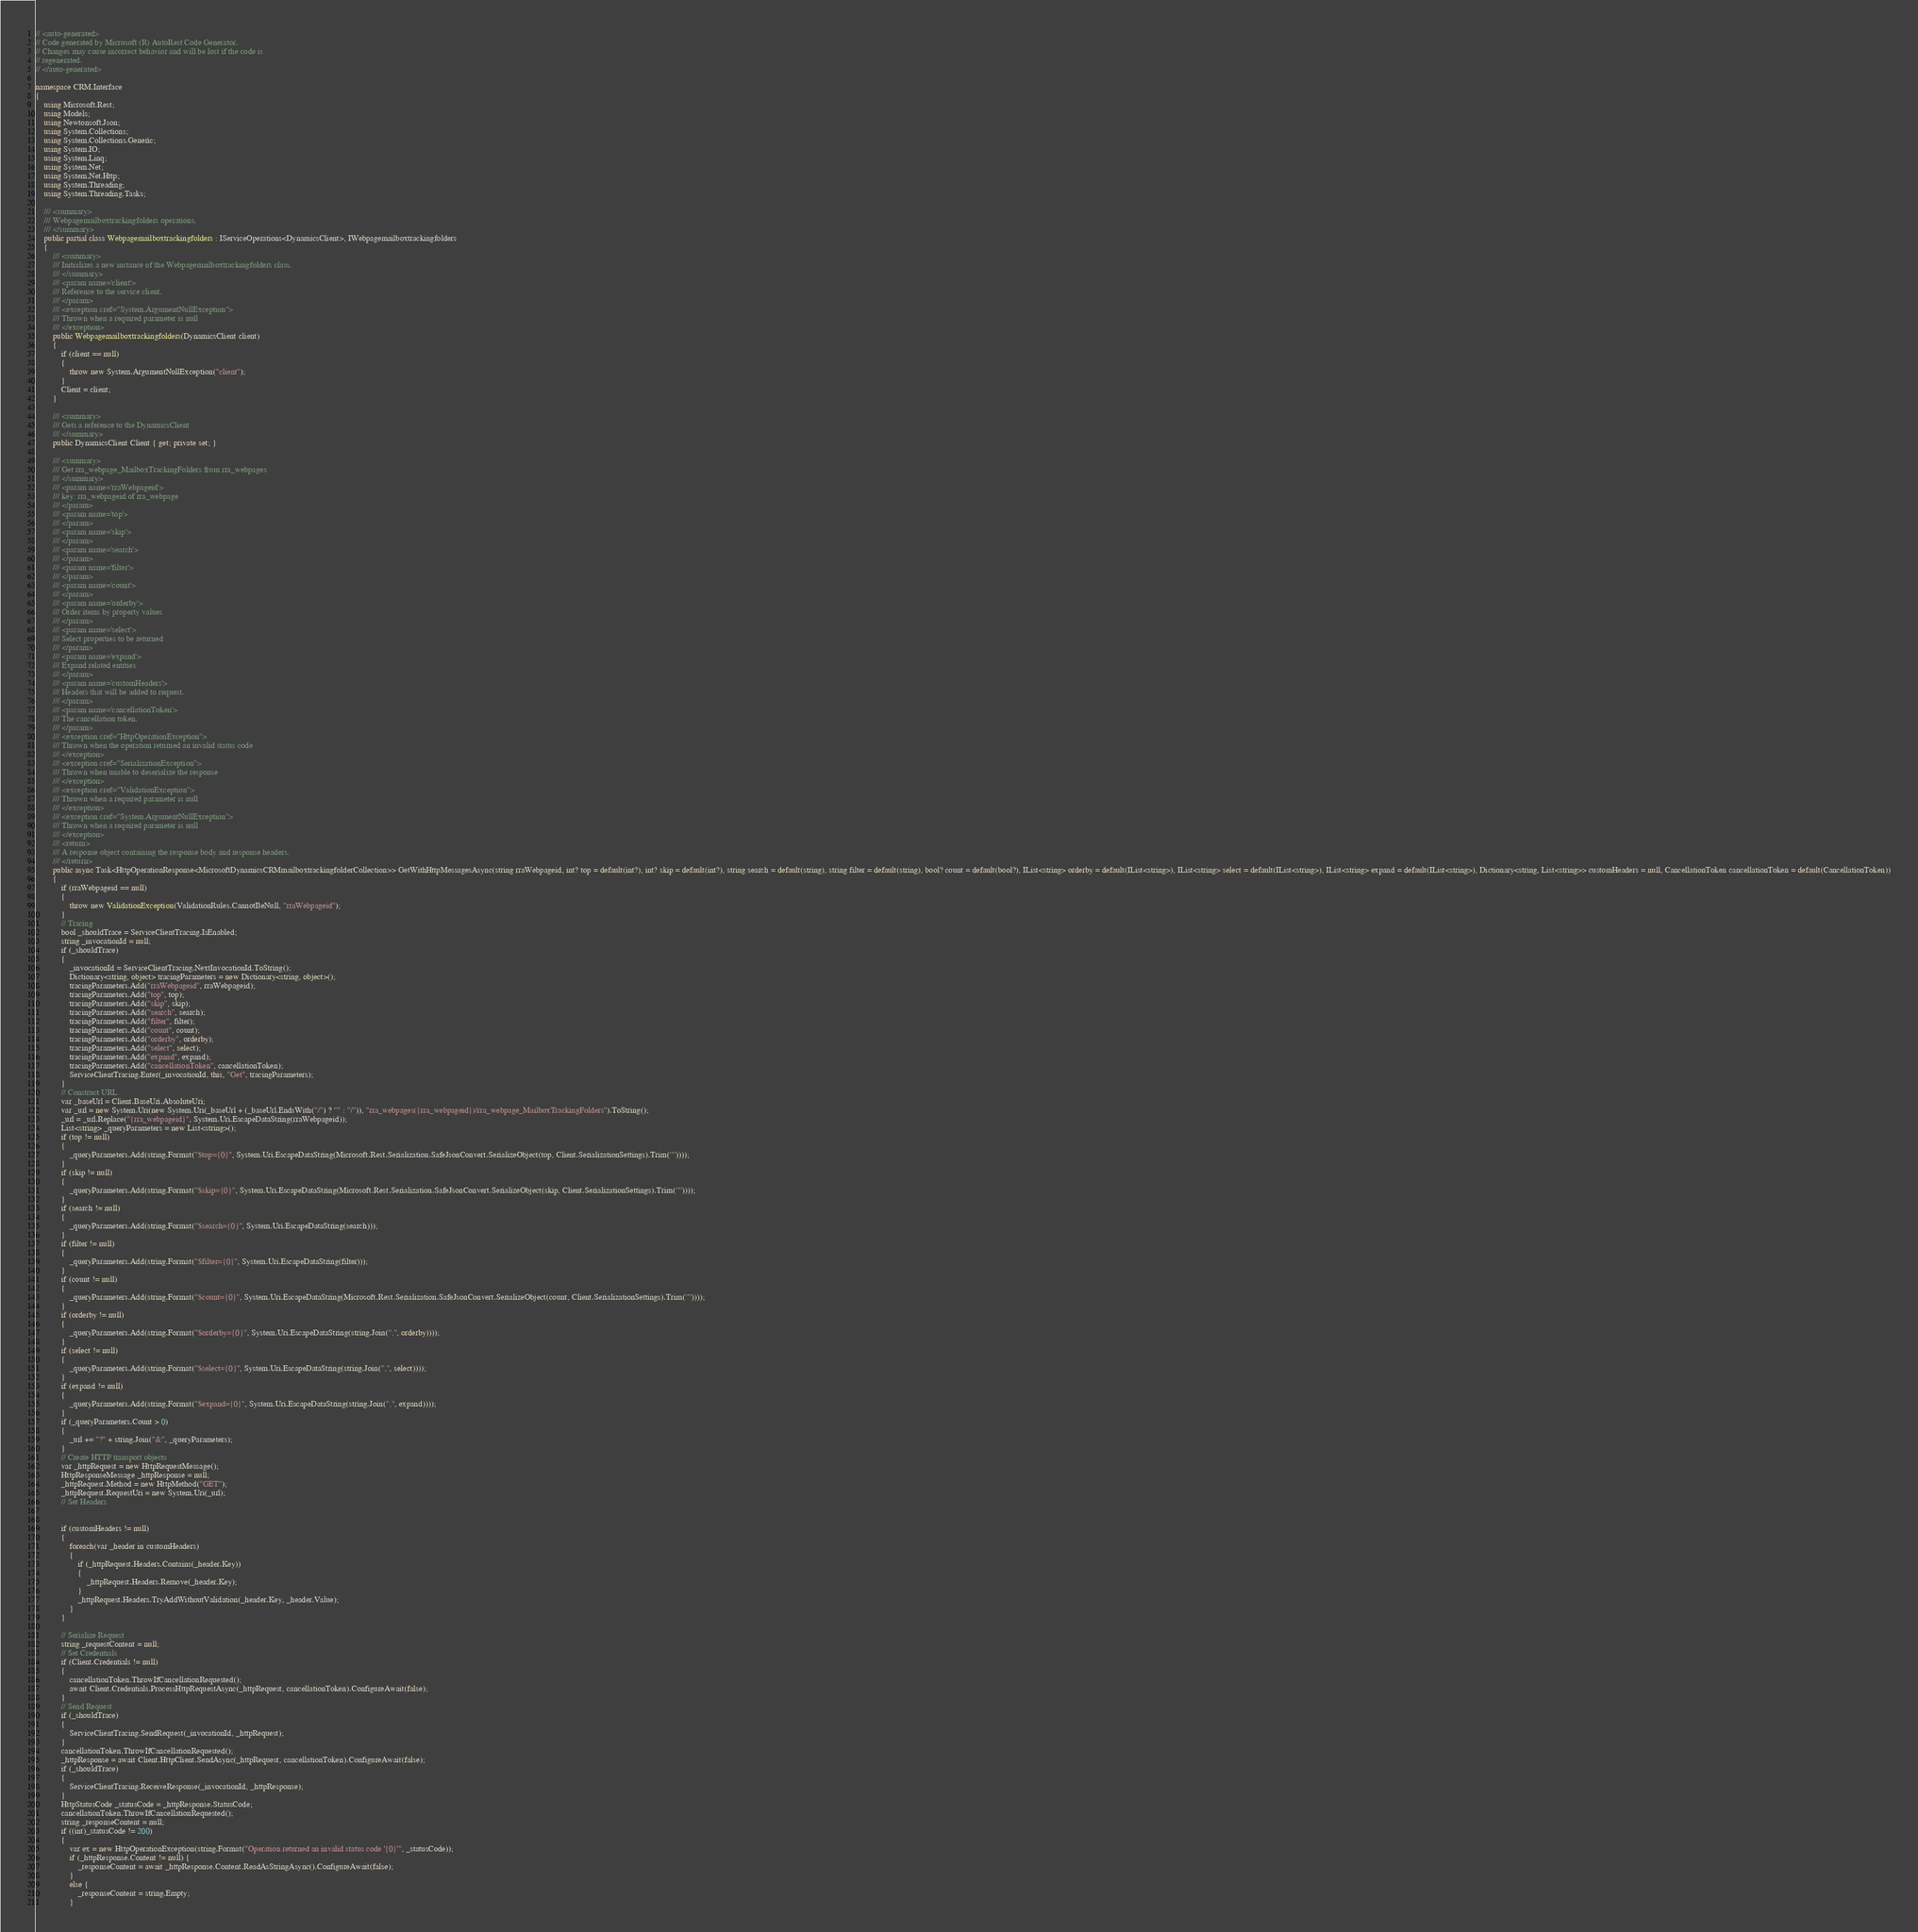Convert code to text. <code><loc_0><loc_0><loc_500><loc_500><_C#_>// <auto-generated>
// Code generated by Microsoft (R) AutoRest Code Generator.
// Changes may cause incorrect behavior and will be lost if the code is
// regenerated.
// </auto-generated>

namespace CRM.Interface
{
    using Microsoft.Rest;
    using Models;
    using Newtonsoft.Json;
    using System.Collections;
    using System.Collections.Generic;
    using System.IO;
    using System.Linq;
    using System.Net;
    using System.Net.Http;
    using System.Threading;
    using System.Threading.Tasks;

    /// <summary>
    /// Webpagemailboxtrackingfolders operations.
    /// </summary>
    public partial class Webpagemailboxtrackingfolders : IServiceOperations<DynamicsClient>, IWebpagemailboxtrackingfolders
    {
        /// <summary>
        /// Initializes a new instance of the Webpagemailboxtrackingfolders class.
        /// </summary>
        /// <param name='client'>
        /// Reference to the service client.
        /// </param>
        /// <exception cref="System.ArgumentNullException">
        /// Thrown when a required parameter is null
        /// </exception>
        public Webpagemailboxtrackingfolders(DynamicsClient client)
        {
            if (client == null)
            {
                throw new System.ArgumentNullException("client");
            }
            Client = client;
        }

        /// <summary>
        /// Gets a reference to the DynamicsClient
        /// </summary>
        public DynamicsClient Client { get; private set; }

        /// <summary>
        /// Get rra_webpage_MailboxTrackingFolders from rra_webpages
        /// </summary>
        /// <param name='rraWebpageid'>
        /// key: rra_webpageid of rra_webpage
        /// </param>
        /// <param name='top'>
        /// </param>
        /// <param name='skip'>
        /// </param>
        /// <param name='search'>
        /// </param>
        /// <param name='filter'>
        /// </param>
        /// <param name='count'>
        /// </param>
        /// <param name='orderby'>
        /// Order items by property values
        /// </param>
        /// <param name='select'>
        /// Select properties to be returned
        /// </param>
        /// <param name='expand'>
        /// Expand related entities
        /// </param>
        /// <param name='customHeaders'>
        /// Headers that will be added to request.
        /// </param>
        /// <param name='cancellationToken'>
        /// The cancellation token.
        /// </param>
        /// <exception cref="HttpOperationException">
        /// Thrown when the operation returned an invalid status code
        /// </exception>
        /// <exception cref="SerializationException">
        /// Thrown when unable to deserialize the response
        /// </exception>
        /// <exception cref="ValidationException">
        /// Thrown when a required parameter is null
        /// </exception>
        /// <exception cref="System.ArgumentNullException">
        /// Thrown when a required parameter is null
        /// </exception>
        /// <return>
        /// A response object containing the response body and response headers.
        /// </return>
        public async Task<HttpOperationResponse<MicrosoftDynamicsCRMmailboxtrackingfolderCollection>> GetWithHttpMessagesAsync(string rraWebpageid, int? top = default(int?), int? skip = default(int?), string search = default(string), string filter = default(string), bool? count = default(bool?), IList<string> orderby = default(IList<string>), IList<string> select = default(IList<string>), IList<string> expand = default(IList<string>), Dictionary<string, List<string>> customHeaders = null, CancellationToken cancellationToken = default(CancellationToken))
        {
            if (rraWebpageid == null)
            {
                throw new ValidationException(ValidationRules.CannotBeNull, "rraWebpageid");
            }
            // Tracing
            bool _shouldTrace = ServiceClientTracing.IsEnabled;
            string _invocationId = null;
            if (_shouldTrace)
            {
                _invocationId = ServiceClientTracing.NextInvocationId.ToString();
                Dictionary<string, object> tracingParameters = new Dictionary<string, object>();
                tracingParameters.Add("rraWebpageid", rraWebpageid);
                tracingParameters.Add("top", top);
                tracingParameters.Add("skip", skip);
                tracingParameters.Add("search", search);
                tracingParameters.Add("filter", filter);
                tracingParameters.Add("count", count);
                tracingParameters.Add("orderby", orderby);
                tracingParameters.Add("select", select);
                tracingParameters.Add("expand", expand);
                tracingParameters.Add("cancellationToken", cancellationToken);
                ServiceClientTracing.Enter(_invocationId, this, "Get", tracingParameters);
            }
            // Construct URL
            var _baseUrl = Client.BaseUri.AbsoluteUri;
            var _url = new System.Uri(new System.Uri(_baseUrl + (_baseUrl.EndsWith("/") ? "" : "/")), "rra_webpages({rra_webpageid})/rra_webpage_MailboxTrackingFolders").ToString();
            _url = _url.Replace("{rra_webpageid}", System.Uri.EscapeDataString(rraWebpageid));
            List<string> _queryParameters = new List<string>();
            if (top != null)
            {
                _queryParameters.Add(string.Format("$top={0}", System.Uri.EscapeDataString(Microsoft.Rest.Serialization.SafeJsonConvert.SerializeObject(top, Client.SerializationSettings).Trim('"'))));
            }
            if (skip != null)
            {
                _queryParameters.Add(string.Format("$skip={0}", System.Uri.EscapeDataString(Microsoft.Rest.Serialization.SafeJsonConvert.SerializeObject(skip, Client.SerializationSettings).Trim('"'))));
            }
            if (search != null)
            {
                _queryParameters.Add(string.Format("$search={0}", System.Uri.EscapeDataString(search)));
            }
            if (filter != null)
            {
                _queryParameters.Add(string.Format("$filter={0}", System.Uri.EscapeDataString(filter)));
            }
            if (count != null)
            {
                _queryParameters.Add(string.Format("$count={0}", System.Uri.EscapeDataString(Microsoft.Rest.Serialization.SafeJsonConvert.SerializeObject(count, Client.SerializationSettings).Trim('"'))));
            }
            if (orderby != null)
            {
                _queryParameters.Add(string.Format("$orderby={0}", System.Uri.EscapeDataString(string.Join(",", orderby))));
            }
            if (select != null)
            {
                _queryParameters.Add(string.Format("$select={0}", System.Uri.EscapeDataString(string.Join(",", select))));
            }
            if (expand != null)
            {
                _queryParameters.Add(string.Format("$expand={0}", System.Uri.EscapeDataString(string.Join(",", expand))));
            }
            if (_queryParameters.Count > 0)
            {
                _url += "?" + string.Join("&", _queryParameters);
            }
            // Create HTTP transport objects
            var _httpRequest = new HttpRequestMessage();
            HttpResponseMessage _httpResponse = null;
            _httpRequest.Method = new HttpMethod("GET");
            _httpRequest.RequestUri = new System.Uri(_url);
            // Set Headers


            if (customHeaders != null)
            {
                foreach(var _header in customHeaders)
                {
                    if (_httpRequest.Headers.Contains(_header.Key))
                    {
                        _httpRequest.Headers.Remove(_header.Key);
                    }
                    _httpRequest.Headers.TryAddWithoutValidation(_header.Key, _header.Value);
                }
            }

            // Serialize Request
            string _requestContent = null;
            // Set Credentials
            if (Client.Credentials != null)
            {
                cancellationToken.ThrowIfCancellationRequested();
                await Client.Credentials.ProcessHttpRequestAsync(_httpRequest, cancellationToken).ConfigureAwait(false);
            }
            // Send Request
            if (_shouldTrace)
            {
                ServiceClientTracing.SendRequest(_invocationId, _httpRequest);
            }
            cancellationToken.ThrowIfCancellationRequested();
            _httpResponse = await Client.HttpClient.SendAsync(_httpRequest, cancellationToken).ConfigureAwait(false);
            if (_shouldTrace)
            {
                ServiceClientTracing.ReceiveResponse(_invocationId, _httpResponse);
            }
            HttpStatusCode _statusCode = _httpResponse.StatusCode;
            cancellationToken.ThrowIfCancellationRequested();
            string _responseContent = null;
            if ((int)_statusCode != 200)
            {
                var ex = new HttpOperationException(string.Format("Operation returned an invalid status code '{0}'", _statusCode));
                if (_httpResponse.Content != null) {
                    _responseContent = await _httpResponse.Content.ReadAsStringAsync().ConfigureAwait(false);
                }
                else {
                    _responseContent = string.Empty;
                }</code> 